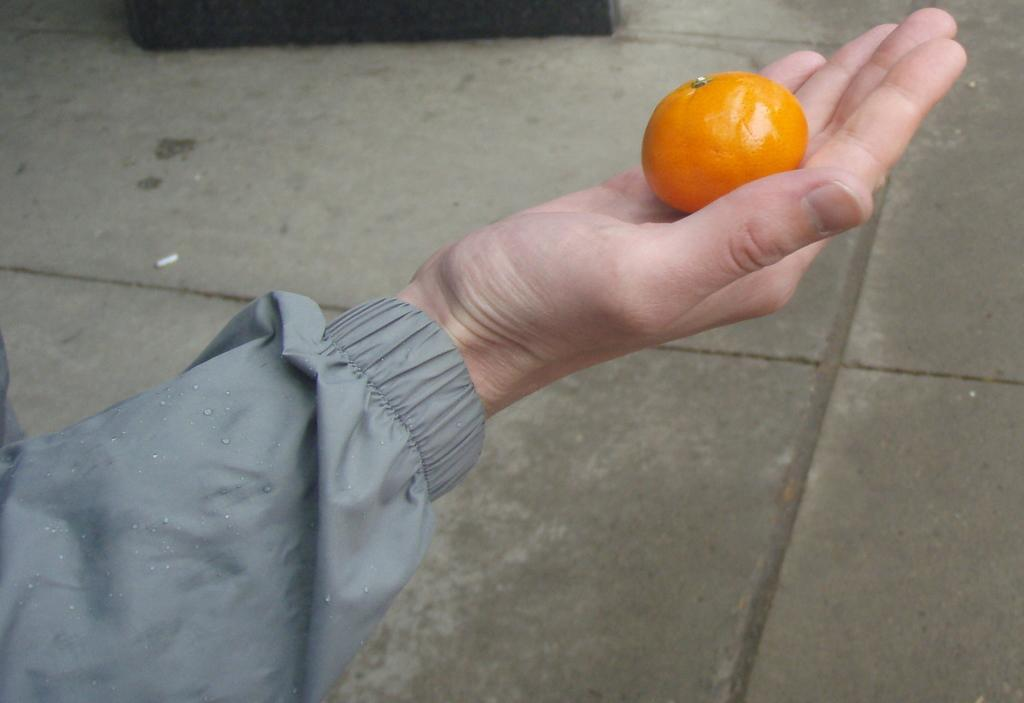What part of a person can be seen in the image? There is a hand of a person in the image. What color is the object that is visible in the image? There is an orange-colored object in the image. What type of news can be heard in the background of the image? There is no indication of any news or sound in the image, as it only shows a hand and an orange-colored object. How many dogs are visible in the image? There are no dogs present in the image. 